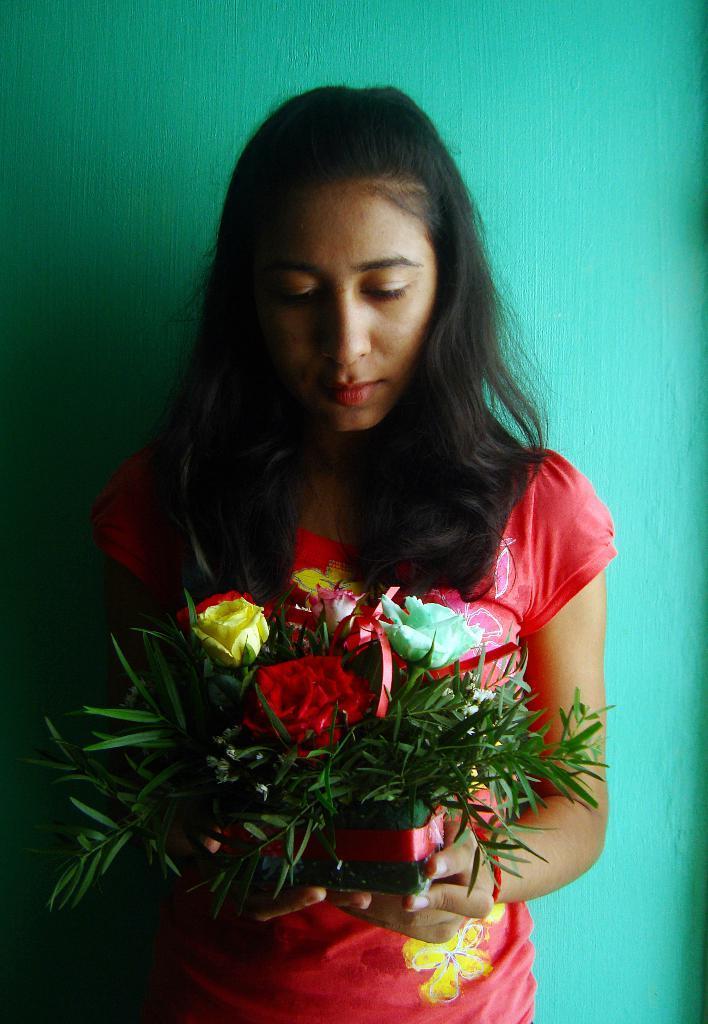How would you summarize this image in a sentence or two? In this image there is one woman standing in middle of this image is holding some flowers and there is a wall in the background. 